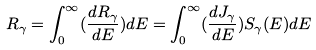<formula> <loc_0><loc_0><loc_500><loc_500>R _ { \gamma } = \int _ { 0 } ^ { \infty } ( \frac { d R _ { \gamma } } { d E } ) d E = \int _ { 0 } ^ { \infty } ( \frac { d J _ { \gamma } } { d E } ) S _ { \gamma } ( E ) d E</formula> 